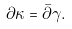Convert formula to latex. <formula><loc_0><loc_0><loc_500><loc_500>\partial \kappa = \bar { \partial } \gamma .</formula> 